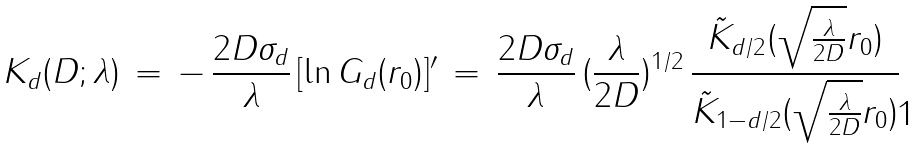Convert formula to latex. <formula><loc_0><loc_0><loc_500><loc_500>K _ { d } ( D ; \lambda ) \, = \, - \, \frac { 2 D \sigma _ { d } } { \lambda } \, [ \ln G _ { d } ( r _ { 0 } ) ] ^ { \prime } \, = \, \frac { 2 D \sigma _ { d } } { \lambda } \, ( \frac { \lambda } { 2 D } ) ^ { 1 / 2 } \, \frac { \tilde { K } _ { d / 2 } ( \sqrt { \frac { \lambda } { 2 D } } r _ { 0 } ) } { \tilde { K } _ { 1 - d / 2 } ( \sqrt { \frac { \lambda } { 2 D } } r _ { 0 } ) }</formula> 